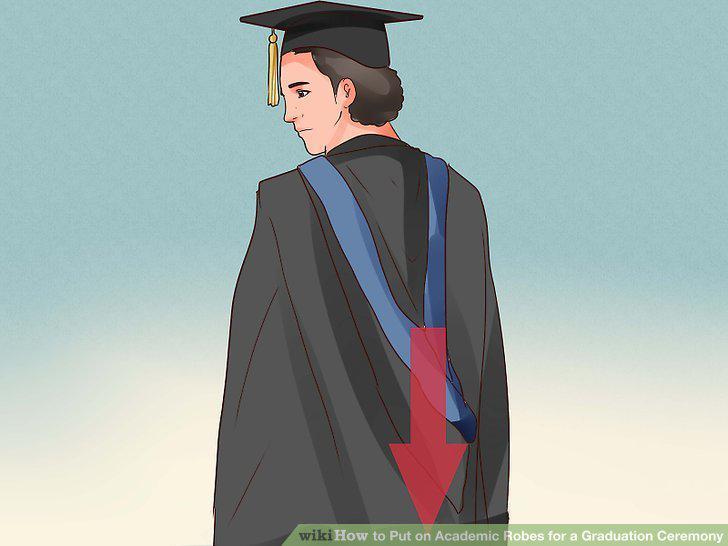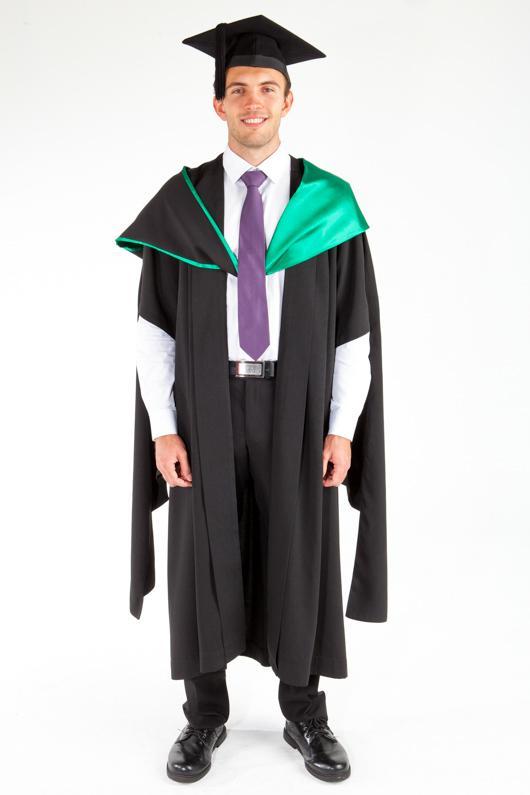The first image is the image on the left, the second image is the image on the right. Evaluate the accuracy of this statement regarding the images: "The man on the left has a yellow tassel.". Is it true? Answer yes or no. Yes. 